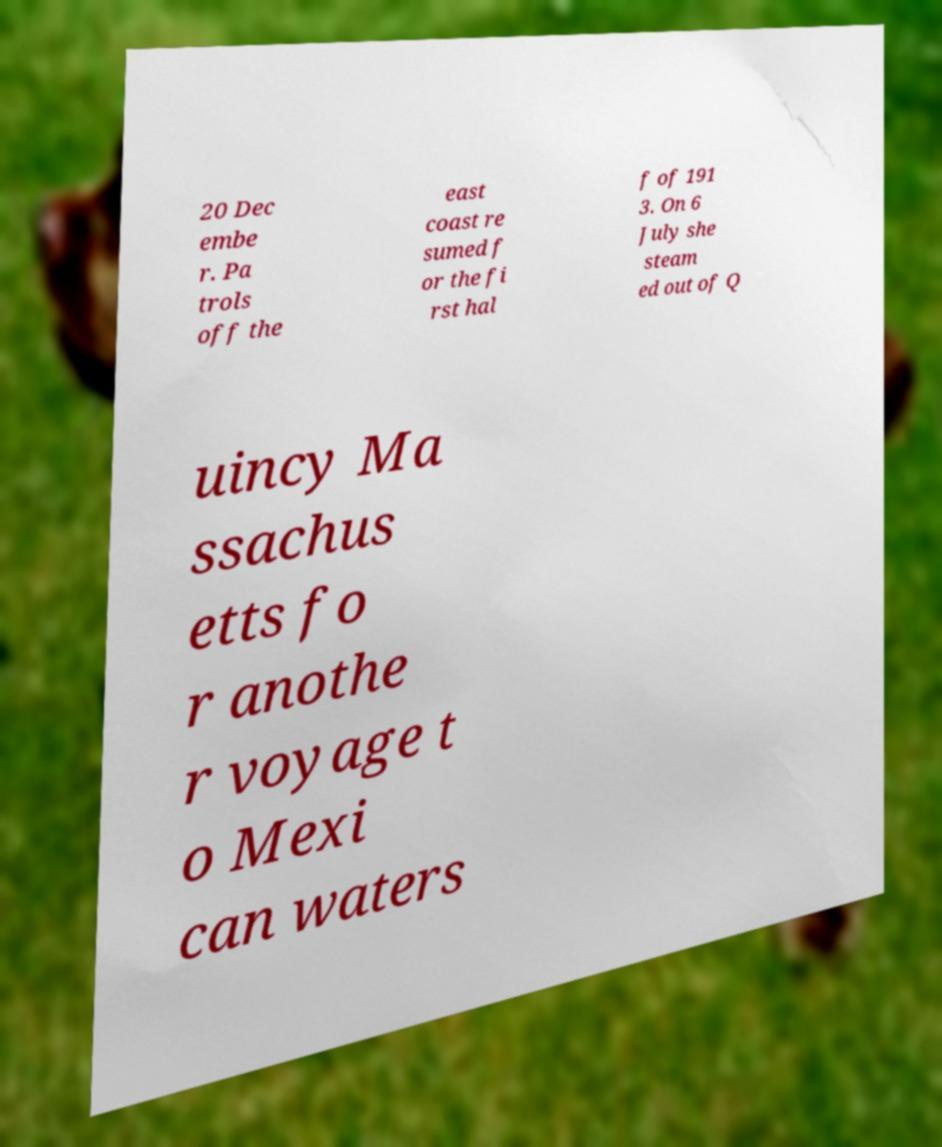Please read and relay the text visible in this image. What does it say? 20 Dec embe r. Pa trols off the east coast re sumed f or the fi rst hal f of 191 3. On 6 July she steam ed out of Q uincy Ma ssachus etts fo r anothe r voyage t o Mexi can waters 